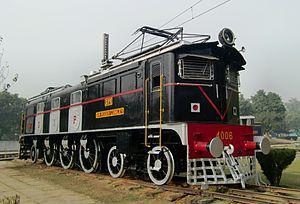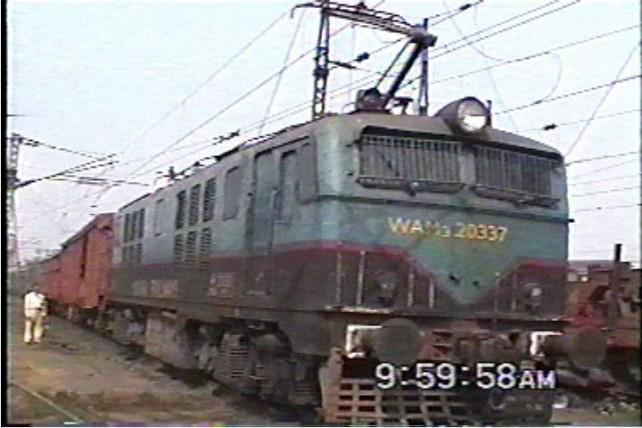The first image is the image on the left, the second image is the image on the right. For the images shown, is this caption "The top of one of the trains is blue." true? Answer yes or no. Yes. 